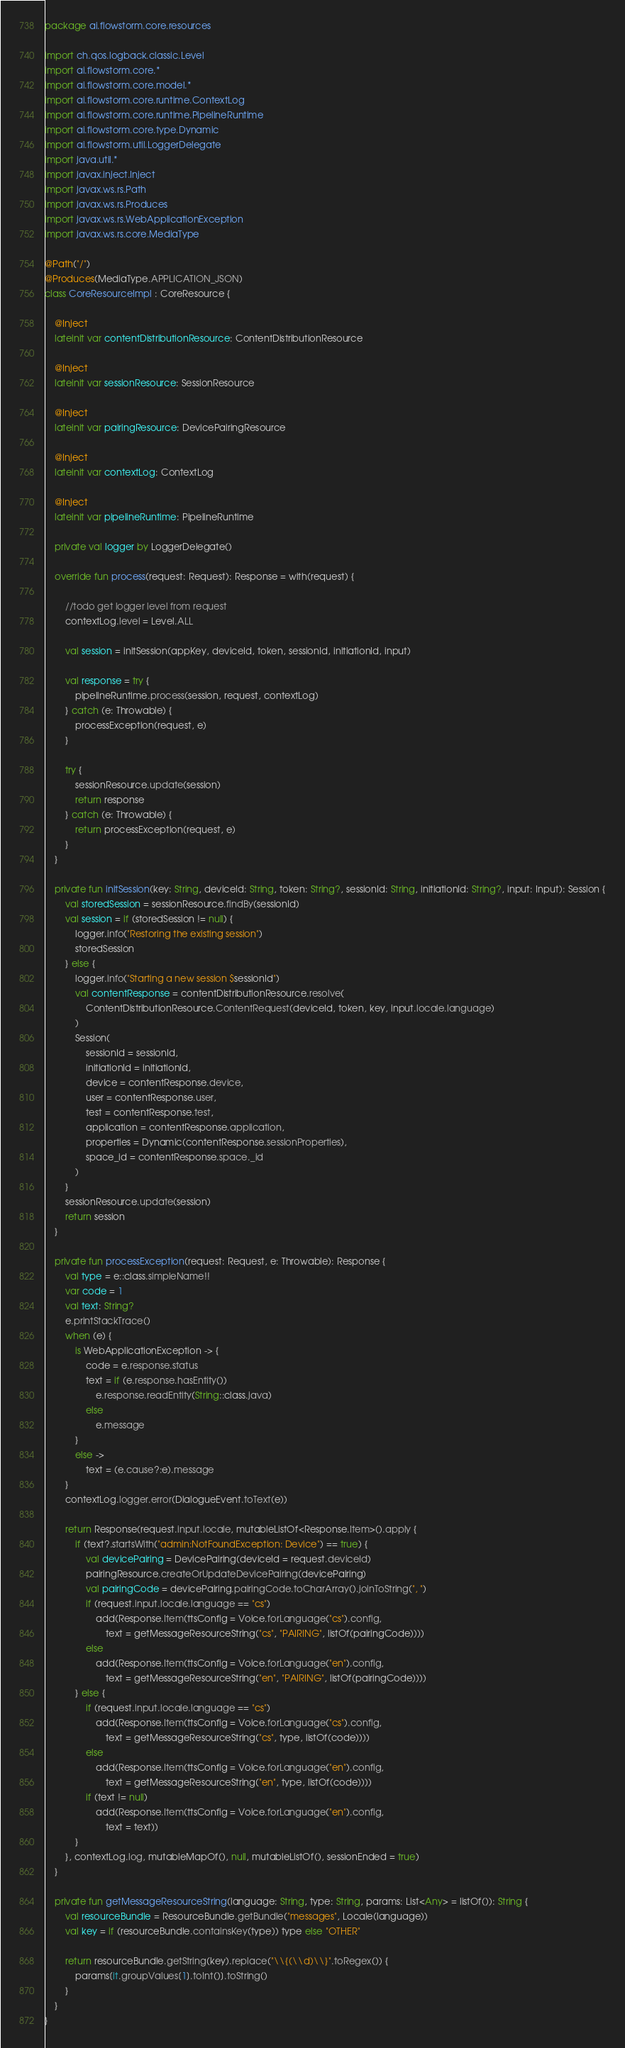Convert code to text. <code><loc_0><loc_0><loc_500><loc_500><_Kotlin_>package ai.flowstorm.core.resources

import ch.qos.logback.classic.Level
import ai.flowstorm.core.*
import ai.flowstorm.core.model.*
import ai.flowstorm.core.runtime.ContextLog
import ai.flowstorm.core.runtime.PipelineRuntime
import ai.flowstorm.core.type.Dynamic
import ai.flowstorm.util.LoggerDelegate
import java.util.*
import javax.inject.Inject
import javax.ws.rs.Path
import javax.ws.rs.Produces
import javax.ws.rs.WebApplicationException
import javax.ws.rs.core.MediaType

@Path("/")
@Produces(MediaType.APPLICATION_JSON)
class CoreResourceImpl : CoreResource {

    @Inject
    lateinit var contentDistributionResource: ContentDistributionResource

    @Inject
    lateinit var sessionResource: SessionResource

    @Inject
    lateinit var pairingResource: DevicePairingResource

    @Inject
    lateinit var contextLog: ContextLog

    @Inject
    lateinit var pipelineRuntime: PipelineRuntime

    private val logger by LoggerDelegate()

    override fun process(request: Request): Response = with(request) {

        //todo get logger level from request
        contextLog.level = Level.ALL

        val session = initSession(appKey, deviceId, token, sessionId, initiationId, input)

        val response = try {
            pipelineRuntime.process(session, request, contextLog)
        } catch (e: Throwable) {
            processException(request, e)
        }

        try {
            sessionResource.update(session)
            return response
        } catch (e: Throwable) {
            return processException(request, e)
        }
    }

    private fun initSession(key: String, deviceId: String, token: String?, sessionId: String, initiationId: String?, input: Input): Session {
        val storedSession = sessionResource.findBy(sessionId)
        val session = if (storedSession != null) {
            logger.info("Restoring the existing session")
            storedSession
        } else {
            logger.info("Starting a new session $sessionId")
            val contentResponse = contentDistributionResource.resolve(
                ContentDistributionResource.ContentRequest(deviceId, token, key, input.locale.language)
            )
            Session(
                sessionId = sessionId,
                initiationId = initiationId,
                device = contentResponse.device,
                user = contentResponse.user,
                test = contentResponse.test,
                application = contentResponse.application,
                properties = Dynamic(contentResponse.sessionProperties),
                space_id = contentResponse.space._id
            )
        }
        sessionResource.update(session)
        return session
    }

    private fun processException(request: Request, e: Throwable): Response {
        val type = e::class.simpleName!!
        var code = 1
        val text: String?
        e.printStackTrace()
        when (e) {
            is WebApplicationException -> {
                code = e.response.status
                text = if (e.response.hasEntity())
                    e.response.readEntity(String::class.java)
                else
                    e.message
            }
            else ->
                text = (e.cause?:e).message
        }
        contextLog.logger.error(DialogueEvent.toText(e))

        return Response(request.input.locale, mutableListOf<Response.Item>().apply {
            if (text?.startsWith("admin:NotFoundException: Device") == true) {
                val devicePairing = DevicePairing(deviceId = request.deviceId)
                pairingResource.createOrUpdateDevicePairing(devicePairing)
                val pairingCode = devicePairing.pairingCode.toCharArray().joinToString(", ")
                if (request.input.locale.language == "cs")
                    add(Response.Item(ttsConfig = Voice.forLanguage("cs").config,
                        text = getMessageResourceString("cs", "PAIRING", listOf(pairingCode))))
                else
                    add(Response.Item(ttsConfig = Voice.forLanguage("en").config,
                        text = getMessageResourceString("en", "PAIRING", listOf(pairingCode))))
            } else {
                if (request.input.locale.language == "cs")
                    add(Response.Item(ttsConfig = Voice.forLanguage("cs").config,
                        text = getMessageResourceString("cs", type, listOf(code))))
                else
                    add(Response.Item(ttsConfig = Voice.forLanguage("en").config,
                        text = getMessageResourceString("en", type, listOf(code))))
                if (text != null)
                    add(Response.Item(ttsConfig = Voice.forLanguage("en").config,
                        text = text))
            }
        }, contextLog.log, mutableMapOf(), null, mutableListOf(), sessionEnded = true)
    }

    private fun getMessageResourceString(language: String, type: String, params: List<Any> = listOf()): String {
        val resourceBundle = ResourceBundle.getBundle("messages", Locale(language))
        val key = if (resourceBundle.containsKey(type)) type else "OTHER"

        return resourceBundle.getString(key).replace("\\{(\\d)\\}".toRegex()) {
            params[it.groupValues[1].toInt()].toString()
        }
    }
}</code> 